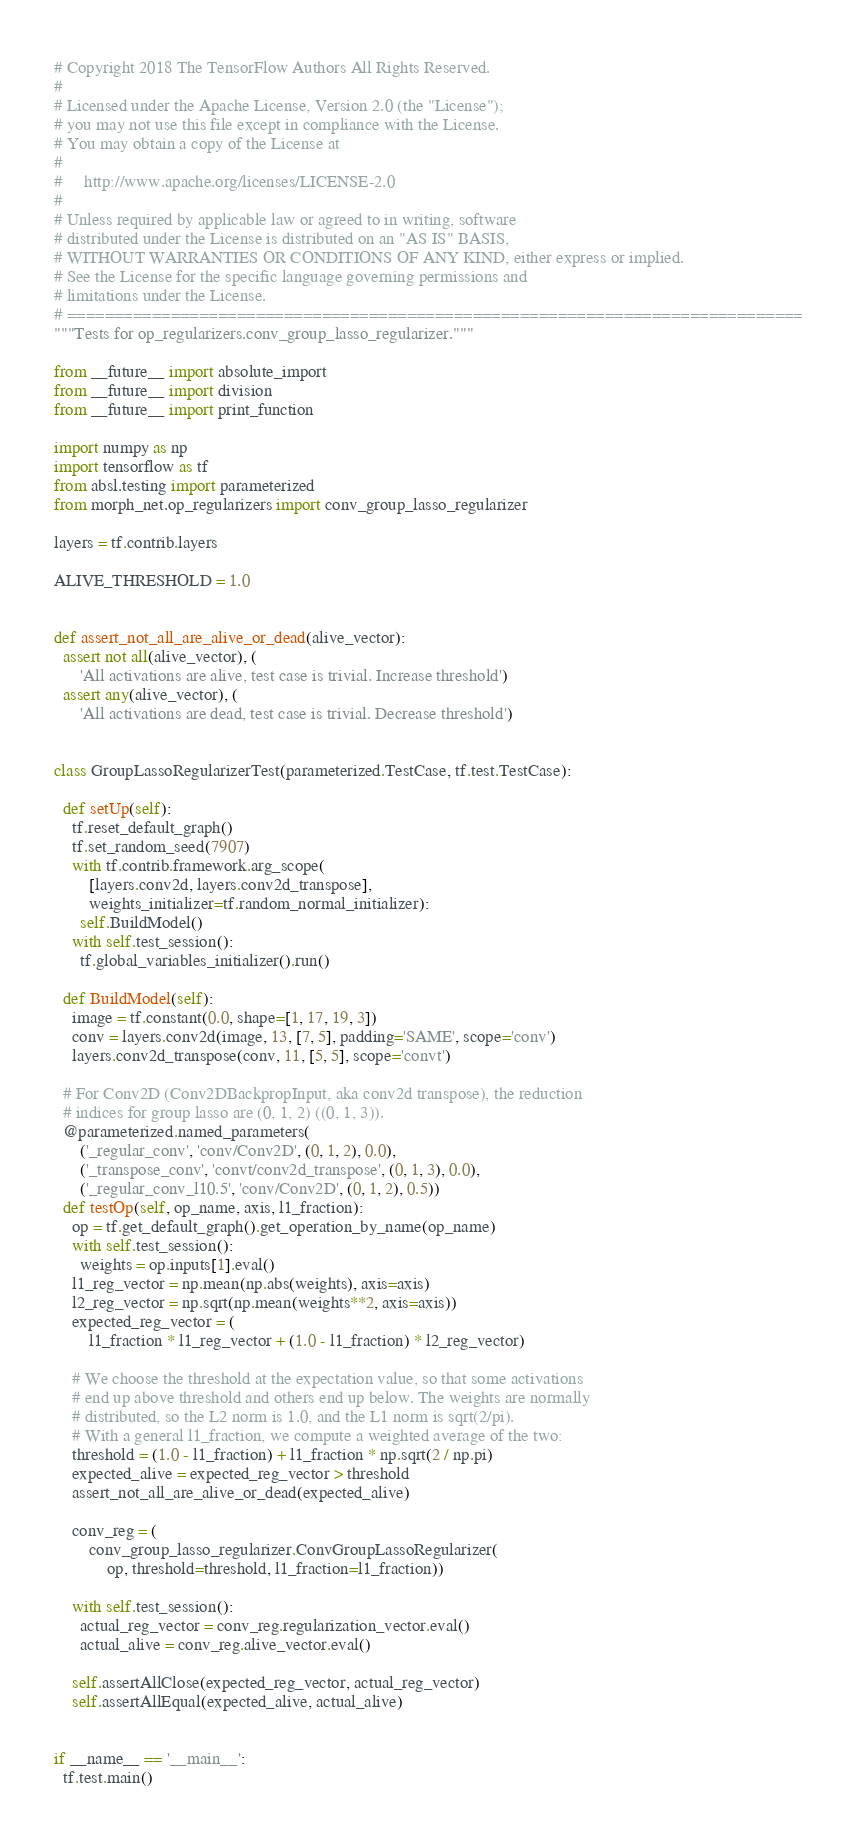Convert code to text. <code><loc_0><loc_0><loc_500><loc_500><_Python_># Copyright 2018 The TensorFlow Authors All Rights Reserved.
#
# Licensed under the Apache License, Version 2.0 (the "License");
# you may not use this file except in compliance with the License.
# You may obtain a copy of the License at
#
#     http://www.apache.org/licenses/LICENSE-2.0
#
# Unless required by applicable law or agreed to in writing, software
# distributed under the License is distributed on an "AS IS" BASIS,
# WITHOUT WARRANTIES OR CONDITIONS OF ANY KIND, either express or implied.
# See the License for the specific language governing permissions and
# limitations under the License.
# ==============================================================================
"""Tests for op_regularizers.conv_group_lasso_regularizer."""

from __future__ import absolute_import
from __future__ import division
from __future__ import print_function

import numpy as np
import tensorflow as tf
from absl.testing import parameterized
from morph_net.op_regularizers import conv_group_lasso_regularizer

layers = tf.contrib.layers

ALIVE_THRESHOLD = 1.0


def assert_not_all_are_alive_or_dead(alive_vector):
  assert not all(alive_vector), (
      'All activations are alive, test case is trivial. Increase threshold')
  assert any(alive_vector), (
      'All activations are dead, test case is trivial. Decrease threshold')


class GroupLassoRegularizerTest(parameterized.TestCase, tf.test.TestCase):

  def setUp(self):
    tf.reset_default_graph()
    tf.set_random_seed(7907)
    with tf.contrib.framework.arg_scope(
        [layers.conv2d, layers.conv2d_transpose],
        weights_initializer=tf.random_normal_initializer):
      self.BuildModel()
    with self.test_session():
      tf.global_variables_initializer().run()

  def BuildModel(self):
    image = tf.constant(0.0, shape=[1, 17, 19, 3])
    conv = layers.conv2d(image, 13, [7, 5], padding='SAME', scope='conv')
    layers.conv2d_transpose(conv, 11, [5, 5], scope='convt')

  # For Conv2D (Conv2DBackpropInput, aka conv2d transpose), the reduction
  # indices for group lasso are (0, 1, 2) ((0, 1, 3)).
  @parameterized.named_parameters(
      ('_regular_conv', 'conv/Conv2D', (0, 1, 2), 0.0),
      ('_transpose_conv', 'convt/conv2d_transpose', (0, 1, 3), 0.0),
      ('_regular_conv_l10.5', 'conv/Conv2D', (0, 1, 2), 0.5))
  def testOp(self, op_name, axis, l1_fraction):
    op = tf.get_default_graph().get_operation_by_name(op_name)
    with self.test_session():
      weights = op.inputs[1].eval()
    l1_reg_vector = np.mean(np.abs(weights), axis=axis)
    l2_reg_vector = np.sqrt(np.mean(weights**2, axis=axis))
    expected_reg_vector = (
        l1_fraction * l1_reg_vector + (1.0 - l1_fraction) * l2_reg_vector)

    # We choose the threshold at the expectation value, so that some activations
    # end up above threshold and others end up below. The weights are normally
    # distributed, so the L2 norm is 1.0, and the L1 norm is sqrt(2/pi).
    # With a general l1_fraction, we compute a weighted average of the two:
    threshold = (1.0 - l1_fraction) + l1_fraction * np.sqrt(2 / np.pi)
    expected_alive = expected_reg_vector > threshold
    assert_not_all_are_alive_or_dead(expected_alive)

    conv_reg = (
        conv_group_lasso_regularizer.ConvGroupLassoRegularizer(
            op, threshold=threshold, l1_fraction=l1_fraction))

    with self.test_session():
      actual_reg_vector = conv_reg.regularization_vector.eval()
      actual_alive = conv_reg.alive_vector.eval()

    self.assertAllClose(expected_reg_vector, actual_reg_vector)
    self.assertAllEqual(expected_alive, actual_alive)


if __name__ == '__main__':
  tf.test.main()
</code> 